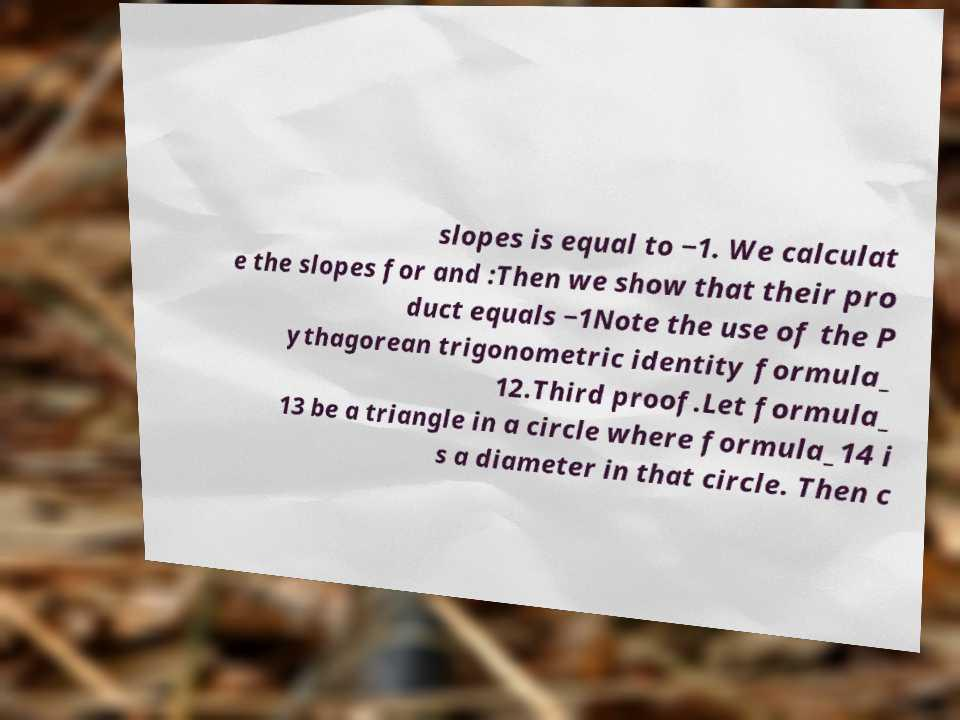I need the written content from this picture converted into text. Can you do that? slopes is equal to −1. We calculat e the slopes for and :Then we show that their pro duct equals −1Note the use of the P ythagorean trigonometric identity formula_ 12.Third proof.Let formula_ 13 be a triangle in a circle where formula_14 i s a diameter in that circle. Then c 